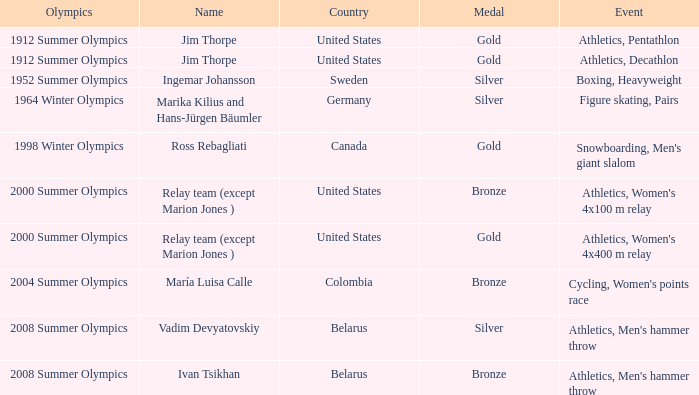Parse the full table. {'header': ['Olympics', 'Name', 'Country', 'Medal', 'Event'], 'rows': [['1912 Summer Olympics', 'Jim Thorpe', 'United States', 'Gold', 'Athletics, Pentathlon'], ['1912 Summer Olympics', 'Jim Thorpe', 'United States', 'Gold', 'Athletics, Decathlon'], ['1952 Summer Olympics', 'Ingemar Johansson', 'Sweden', 'Silver', 'Boxing, Heavyweight'], ['1964 Winter Olympics', 'Marika Kilius and Hans-Jürgen Bäumler', 'Germany', 'Silver', 'Figure skating, Pairs'], ['1998 Winter Olympics', 'Ross Rebagliati', 'Canada', 'Gold', "Snowboarding, Men's giant slalom"], ['2000 Summer Olympics', 'Relay team (except Marion Jones )', 'United States', 'Bronze', "Athletics, Women's 4x100 m relay"], ['2000 Summer Olympics', 'Relay team (except Marion Jones )', 'United States', 'Gold', "Athletics, Women's 4x400 m relay"], ['2004 Summer Olympics', 'María Luisa Calle', 'Colombia', 'Bronze', "Cycling, Women's points race"], ['2008 Summer Olympics', 'Vadim Devyatovskiy', 'Belarus', 'Silver', "Athletics, Men's hammer throw"], ['2008 Summer Olympics', 'Ivan Tsikhan', 'Belarus', 'Bronze', "Athletics, Men's hammer throw"]]} Which event is in the 1952 summer olympics? Boxing, Heavyweight. 